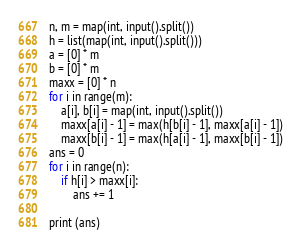Convert code to text. <code><loc_0><loc_0><loc_500><loc_500><_Python_>n, m = map(int, input().split())
h = list(map(int, input().split()))
a = [0] * m
b = [0] * m
maxx = [0] * n
for i in range(m):
    a[i], b[i] = map(int, input().split())
    maxx[a[i] - 1] = max(h[b[i] - 1], maxx[a[i] - 1])
    maxx[b[i] - 1] = max(h[a[i] - 1], maxx[b[i] - 1])
ans = 0
for i in range(n):
    if h[i] > maxx[i]:
        ans += 1

print (ans)</code> 